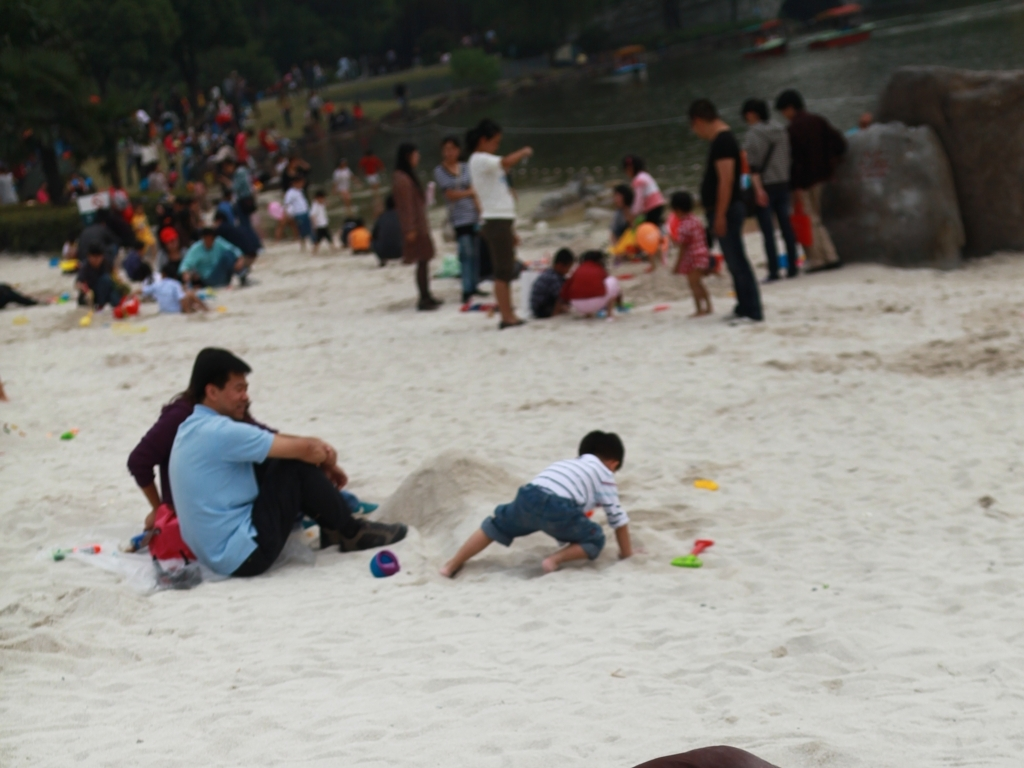What activity is taking place in the foreground? In the foreground, there appears to be a child playing in the sand, possibly building something or simply enjoying tactile play. An adult is seated nearby, which suggests a family outing to a sandy area, such as a beach or a sandpit in a park. 